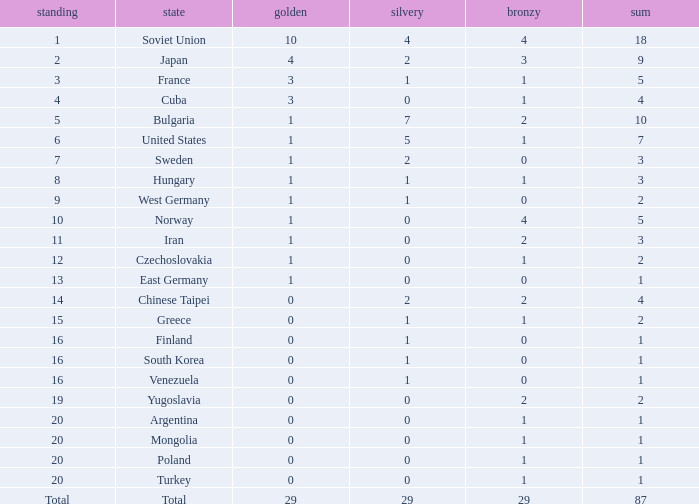Across all nations, what is the typical number of bronze medals won? 29.0. 